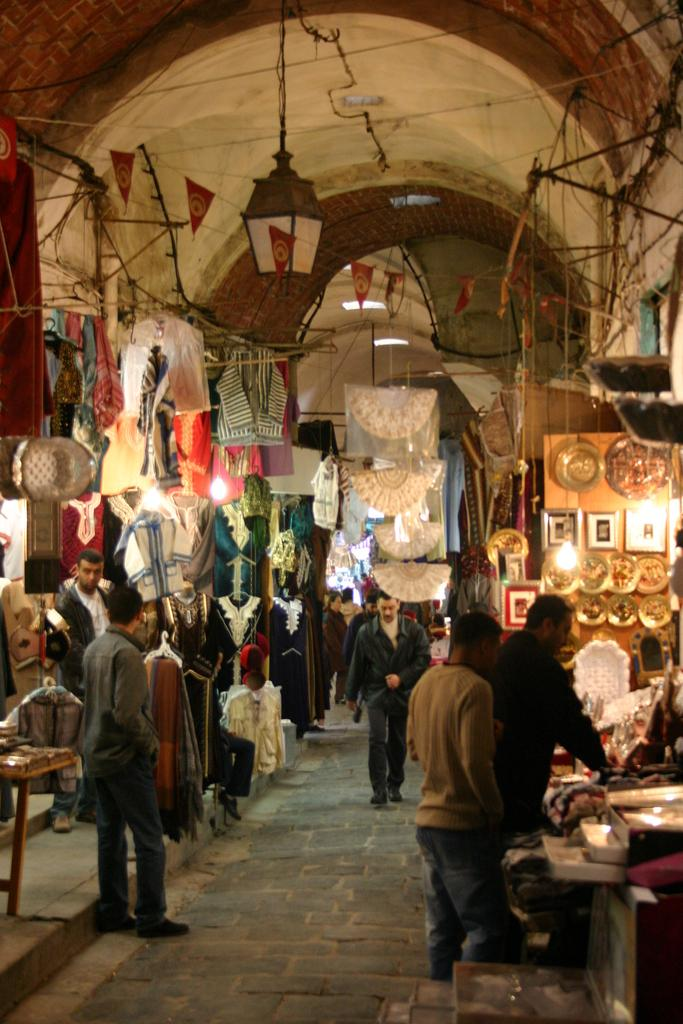What are the people at the bottom of the image doing? The people standing and walking at the bottom of the image are moving around. What can be seen behind the people? There are clothes visible behind the people. What type of illumination is present in the image? There are lights visible in the image. What is visible at the top of the image? The ceiling is visible at the top of the image, and banners are present there. How does the expert wind the banners at the top of the image? There is no expert or wind present in the image; the banners are stationary. 